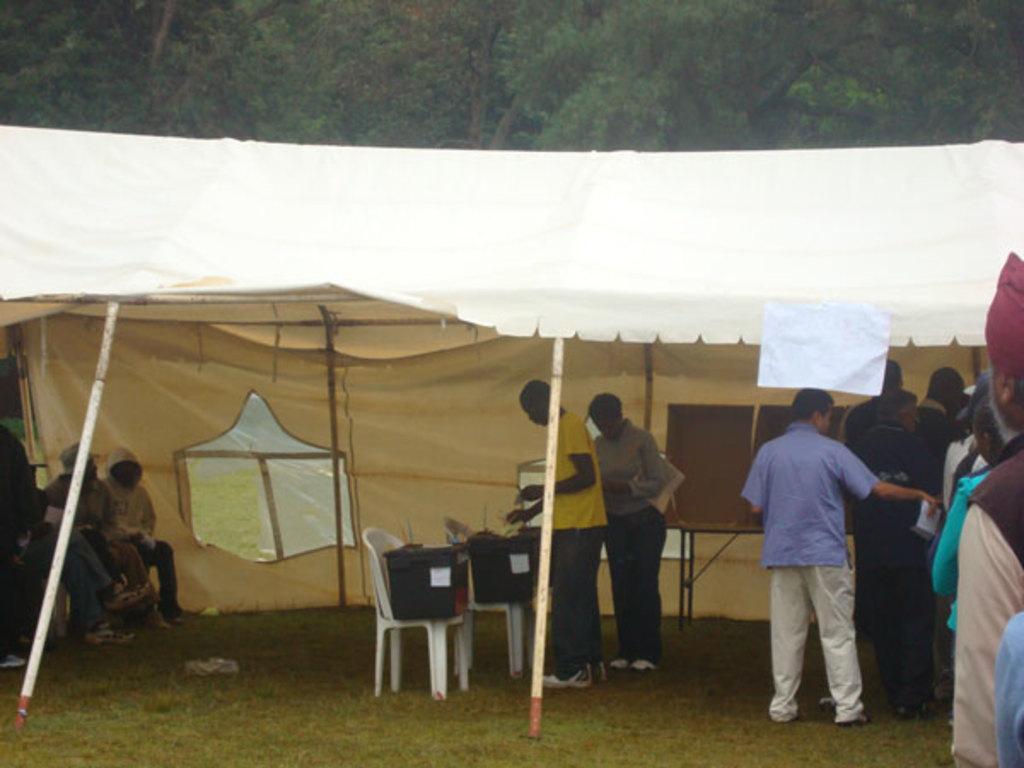In one or two sentences, can you explain what this image depicts? In this picture I can see group of people among them some are standing and some are sitting. Here I can see tent, white color chairs on which I can see some objects. In the background I can see trees. 